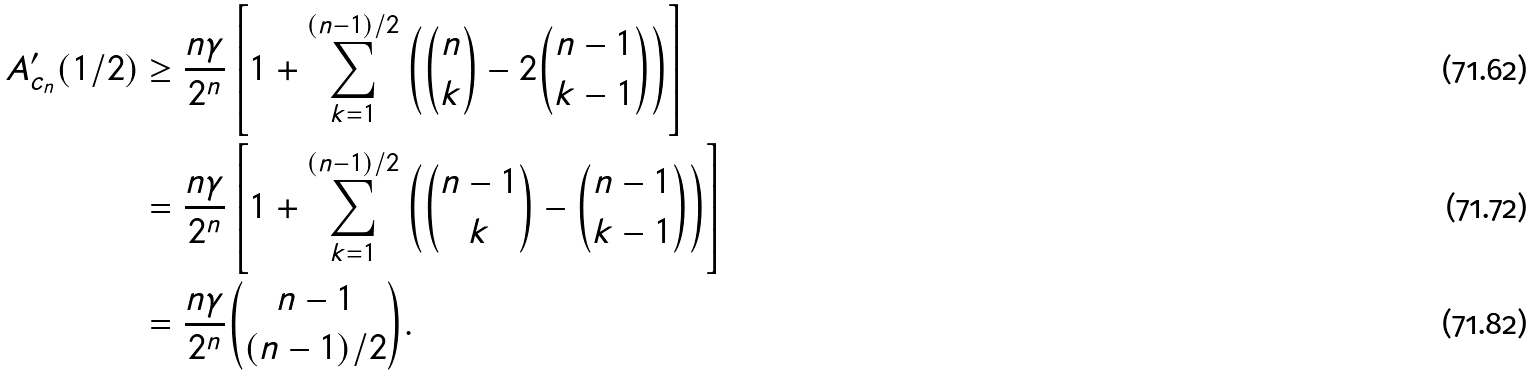Convert formula to latex. <formula><loc_0><loc_0><loc_500><loc_500>A _ { c _ { n } } ^ { \prime } ( 1 / 2 ) & \geq \frac { n \gamma } { 2 ^ { n } } \left [ 1 + \sum _ { k = 1 } ^ { ( n - 1 ) / 2 } \left ( { n \choose k } - 2 { n - 1 \choose k - 1 } \right ) \right ] \\ & = \frac { n \gamma } { 2 ^ { n } } \left [ 1 + \sum _ { k = 1 } ^ { ( n - 1 ) / 2 } \left ( { n - 1 \choose k } - { n - 1 \choose k - 1 } \right ) \right ] \\ & = \frac { n \gamma } { 2 ^ { n } } { n - 1 \choose ( n - 1 ) / 2 } .</formula> 